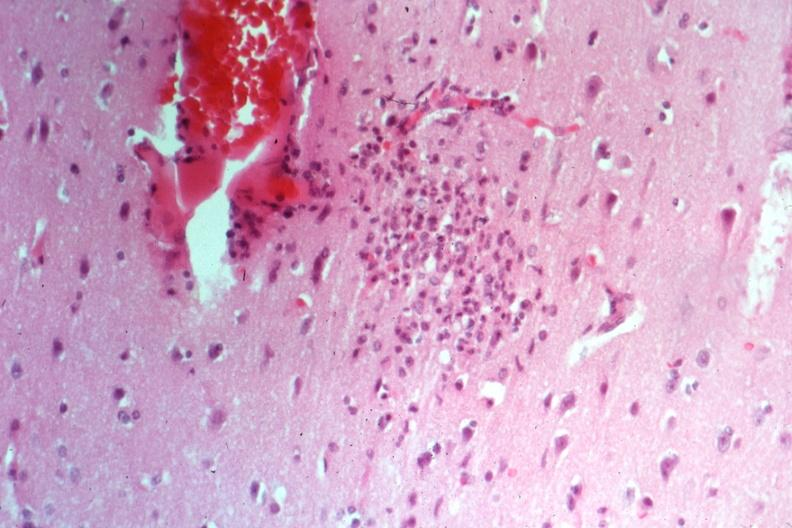what is present?
Answer the question using a single word or phrase. Glial nodule 